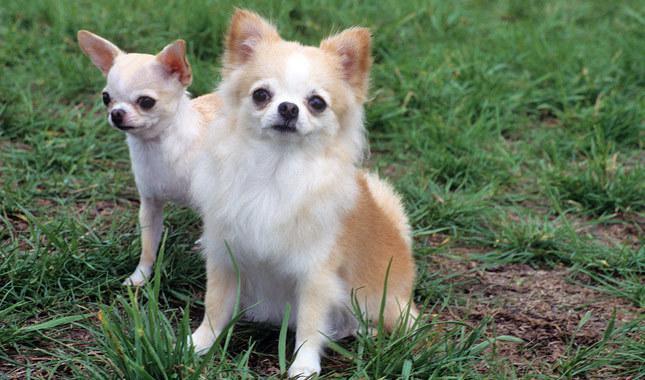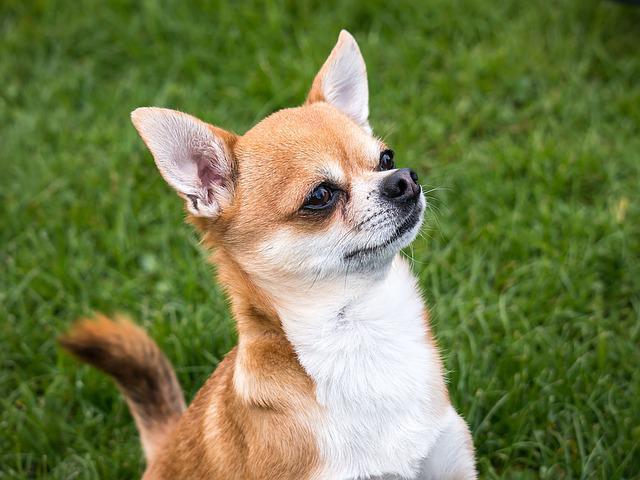The first image is the image on the left, the second image is the image on the right. Evaluate the accuracy of this statement regarding the images: "there are two dogs whose full body is shown on the image". Is it true? Answer yes or no. No. 